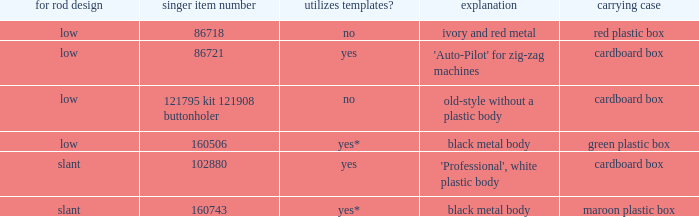What's the description of the buttonholer whose singer part number is 121795 kit 121908 buttonholer? Old-style without a plastic body. 